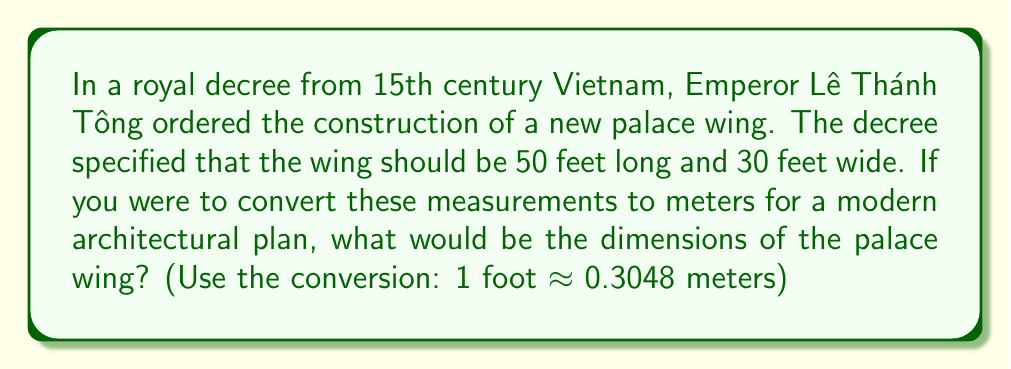Provide a solution to this math problem. To solve this problem, we need to convert the imperial measurements (feet) to metric measurements (meters). We'll use the given conversion factor: 1 foot ≈ 0.3048 meters.

Let's convert each dimension separately:

1. Length:
   $$ 50 \text{ feet} \times 0.3048 \text{ meters/foot} = 15.24 \text{ meters} $$

2. Width:
   $$ 30 \text{ feet} \times 0.3048 \text{ meters/foot} = 9.144 \text{ meters} $$

The calculation is straightforward multiplication. We multiply the number of feet by the conversion factor to get the equivalent length in meters.

It's worth noting that in historical context, the exact length of a "foot" might have varied slightly from the modern definition. However, for the purpose of this conversion, we're using the standard modern conversion factor.
Answer: The dimensions of the palace wing in meters would be approximately 15.24 meters long and 9.14 meters wide. 